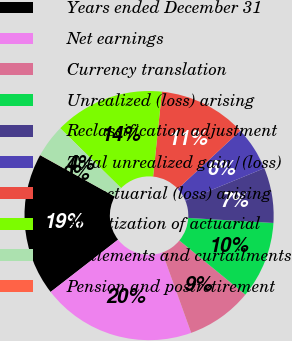<chart> <loc_0><loc_0><loc_500><loc_500><pie_chart><fcel>Years ended December 31<fcel>Net earnings<fcel>Currency translation<fcel>Unrealized (loss) arising<fcel>Reclassification adjustment<fcel>Total unrealized gain/(loss)<fcel>Net actuarial (loss) arising<fcel>Amortization of actuarial<fcel>Settlements and curtailments<fcel>Pension and postretirement<nl><fcel>18.56%<fcel>19.99%<fcel>8.57%<fcel>10.0%<fcel>7.15%<fcel>5.72%<fcel>11.43%<fcel>14.28%<fcel>4.29%<fcel>0.01%<nl></chart> 